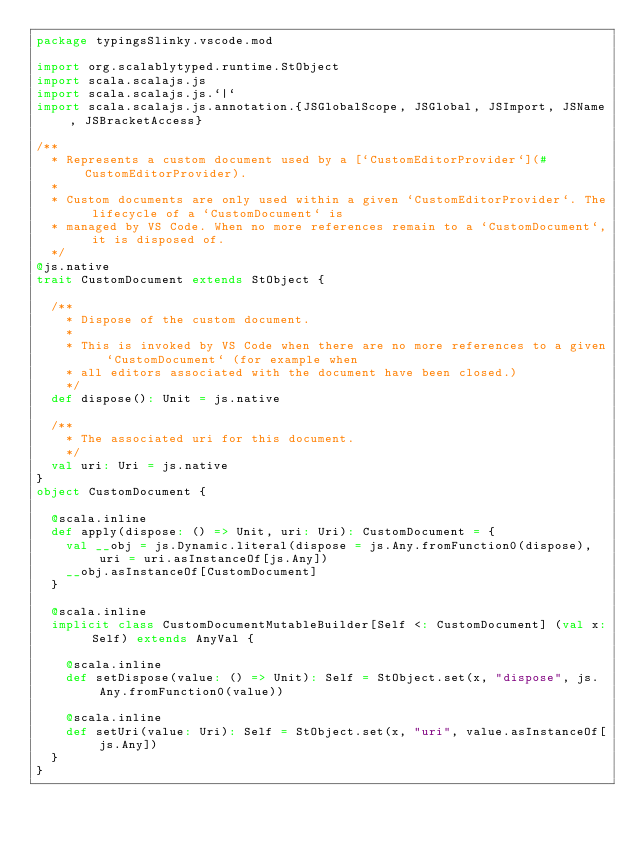<code> <loc_0><loc_0><loc_500><loc_500><_Scala_>package typingsSlinky.vscode.mod

import org.scalablytyped.runtime.StObject
import scala.scalajs.js
import scala.scalajs.js.`|`
import scala.scalajs.js.annotation.{JSGlobalScope, JSGlobal, JSImport, JSName, JSBracketAccess}

/**
  * Represents a custom document used by a [`CustomEditorProvider`](#CustomEditorProvider).
  *
  * Custom documents are only used within a given `CustomEditorProvider`. The lifecycle of a `CustomDocument` is
  * managed by VS Code. When no more references remain to a `CustomDocument`, it is disposed of.
  */
@js.native
trait CustomDocument extends StObject {
  
  /**
    * Dispose of the custom document.
    *
    * This is invoked by VS Code when there are no more references to a given `CustomDocument` (for example when
    * all editors associated with the document have been closed.)
    */
  def dispose(): Unit = js.native
  
  /**
    * The associated uri for this document.
    */
  val uri: Uri = js.native
}
object CustomDocument {
  
  @scala.inline
  def apply(dispose: () => Unit, uri: Uri): CustomDocument = {
    val __obj = js.Dynamic.literal(dispose = js.Any.fromFunction0(dispose), uri = uri.asInstanceOf[js.Any])
    __obj.asInstanceOf[CustomDocument]
  }
  
  @scala.inline
  implicit class CustomDocumentMutableBuilder[Self <: CustomDocument] (val x: Self) extends AnyVal {
    
    @scala.inline
    def setDispose(value: () => Unit): Self = StObject.set(x, "dispose", js.Any.fromFunction0(value))
    
    @scala.inline
    def setUri(value: Uri): Self = StObject.set(x, "uri", value.asInstanceOf[js.Any])
  }
}
</code> 